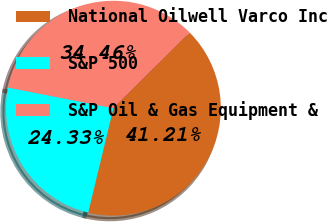Convert chart to OTSL. <chart><loc_0><loc_0><loc_500><loc_500><pie_chart><fcel>National Oilwell Varco Inc<fcel>S&P 500<fcel>S&P Oil & Gas Equipment &<nl><fcel>41.21%<fcel>24.33%<fcel>34.46%<nl></chart> 